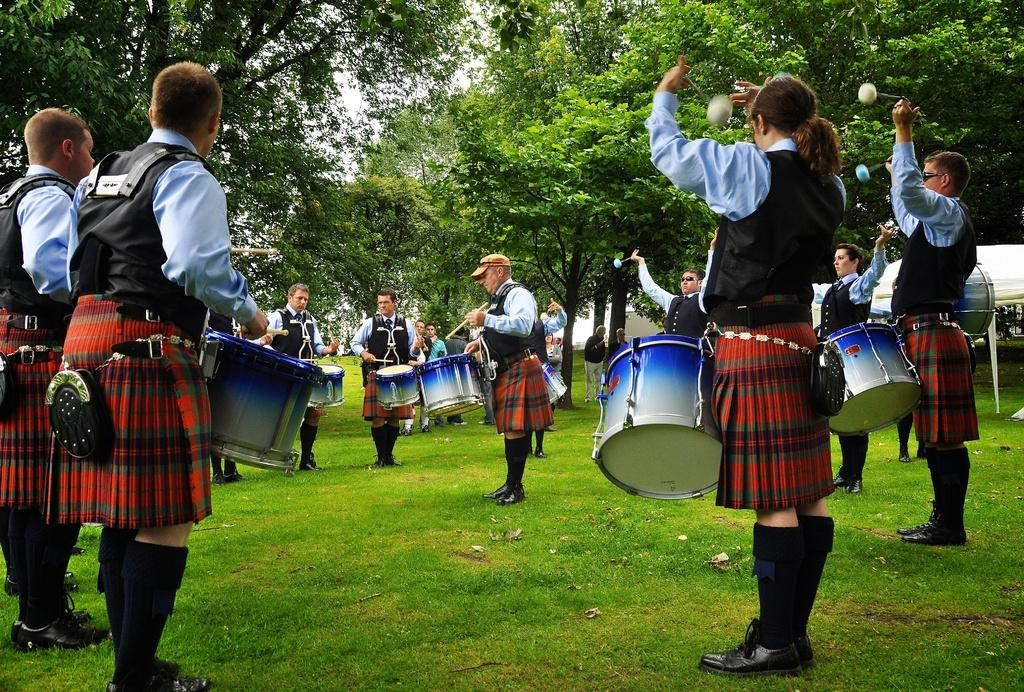What are the people in the image doing? The people in the image are standing on the ground and holding drums and sticks. What is the surface they are standing on? The ground is covered with grass. What can be seen in the background behind the people? There are many trees behind the people. What type of brick pattern can be seen on the people's skirts in the image? There are no skirts present in the image, and therefore no brick patterns can be observed. 